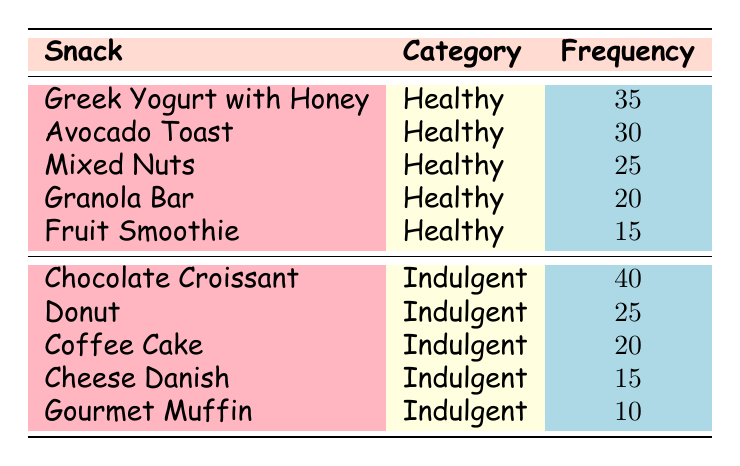What is the most popular snack in the indulgent category? Looking at the table, the snack with the highest frequency in the indulgent category is the Chocolate Croissant, with a frequency of 40.
Answer: Chocolate Croissant How many healthy snacks are listed in the table? The table lists five healthy snacks: Greek Yogurt with Honey, Avocado Toast, Mixed Nuts, Granola Bar, and Fruit Smoothie.
Answer: 5 What is the total frequency of healthy snacks? By summing the frequencies of the healthy snacks: 35 (Greek Yogurt) + 30 (Avocado Toast) + 25 (Mixed Nuts) + 20 (Granola Bar) + 15 (Fruit Smoothie) = 125.
Answer: 125 Is the frequency of Mixed Nuts greater than that of Donut? The frequency of Mixed Nuts is 25, whereas the frequency of Donut is also 25. Therefore, Mixed Nuts is not greater than Donut.
Answer: No What is the frequency difference between the healthiest (most popular) and the least healthy (least popular) snack? The healthiest snack is Greek Yogurt with Honey (frequency 35) and the least popular indulgent snack is Gourmet Muffin (frequency 10). The difference in frequency is 35 - 10 = 25.
Answer: 25 What percentage of all snack choices are healthy? There are 10 snack choices in total. The frequencies of healthy snacks sum to 125. The percentage is calculated as (125/235) * 100 ≈ 53.19%.
Answer: Approximately 53.19% What is the least popular healthy snack? The least popular healthy snack is the Fruit Smoothie, which has a frequency of 15.
Answer: Fruit Smoothie How many more indulgent snacks are there compared to healthy snacks? There are five indulgent snacks (Chocolate Croissant, Donut, Coffee Cake, Cheese Danish, Gourmet Muffin) and five healthy snacks. Thus, there are no more indulgent snacks than healthy snacks.
Answer: 0 Which category has a higher total frequency? The total frequency for healthy snacks is 125, while for indulgent snacks it is 110. Therefore, the healthy category has a higher total frequency than the indulgent category.
Answer: Healthy category 